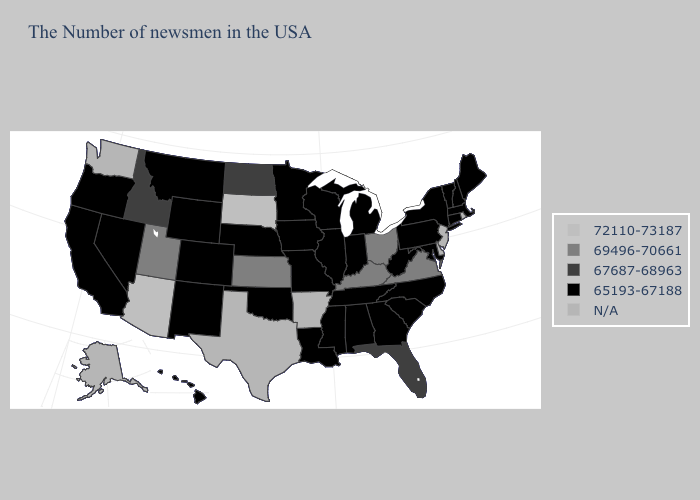Which states hav the highest value in the South?
Write a very short answer. Virginia, Kentucky. Name the states that have a value in the range 67687-68963?
Give a very brief answer. Florida, North Dakota, Idaho. Which states hav the highest value in the South?
Be succinct. Virginia, Kentucky. Does Connecticut have the lowest value in the USA?
Write a very short answer. Yes. Name the states that have a value in the range 67687-68963?
Concise answer only. Florida, North Dakota, Idaho. What is the highest value in states that border Georgia?
Be succinct. 67687-68963. Which states have the lowest value in the USA?
Be succinct. Maine, Massachusetts, New Hampshire, Vermont, Connecticut, New York, Maryland, Pennsylvania, North Carolina, South Carolina, West Virginia, Georgia, Michigan, Indiana, Alabama, Tennessee, Wisconsin, Illinois, Mississippi, Louisiana, Missouri, Minnesota, Iowa, Nebraska, Oklahoma, Wyoming, Colorado, New Mexico, Montana, Nevada, California, Oregon, Hawaii. Does Arizona have the highest value in the USA?
Concise answer only. Yes. What is the value of New York?
Give a very brief answer. 65193-67188. What is the value of Montana?
Answer briefly. 65193-67188. What is the lowest value in the Northeast?
Answer briefly. 65193-67188. 